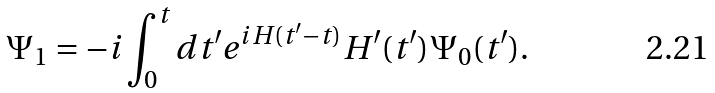<formula> <loc_0><loc_0><loc_500><loc_500>\Psi _ { 1 } = - i \int _ { 0 } ^ { t } d t ^ { \prime } e ^ { i H ( t ^ { \prime } - t ) } H ^ { \prime } ( t ^ { \prime } ) \Psi _ { 0 } ( t ^ { \prime } ) .</formula> 